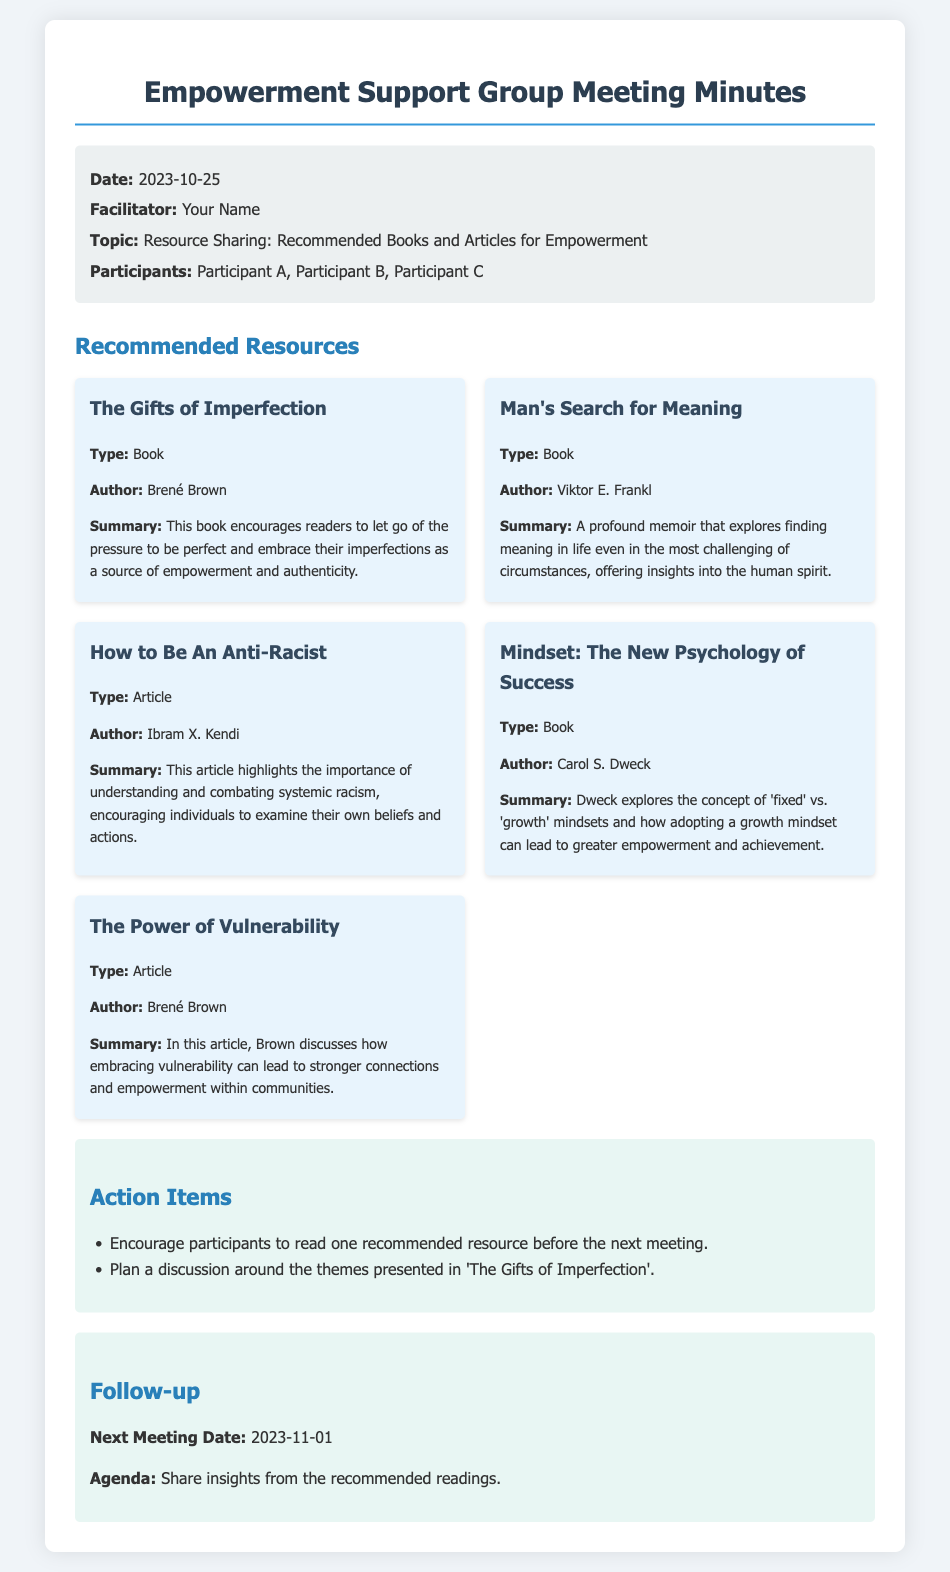What is the date of the meeting? The meeting date is mentioned in the meta-info section of the document.
Answer: 2023-10-25 Who is the facilitator of the meeting? The facilitator's name is provided in the meta-info section.
Answer: Your Name What is the topic discussed in the meeting? The topic is listed clearly in the meta-info section of the document.
Answer: Resource Sharing: Recommended Books and Articles for Empowerment How many participants attended the meeting? The number of participants can be discerned from the participant list in the meta-info section.
Answer: 3 What is one of the recommended resources listed? The document contains a list of recommended resources under the "Recommended Resources" section.
Answer: The Gifts of Imperfection Who is the author of "Man's Search for Meaning"? The author information is provided for each resource in the document.
Answer: Viktor E. Frankl What is one action item from the meeting? Action items are listed under the "Action Items" section in the document.
Answer: Encourage participants to read one recommended resource before the next meeting When is the next meeting scheduled? The next meeting date is stated in the "Follow-up" section of the document.
Answer: 2023-11-01 What is the agenda for the next meeting? The agenda for the next meeting is found in the "Follow-up" section.
Answer: Share insights from the recommended readings 